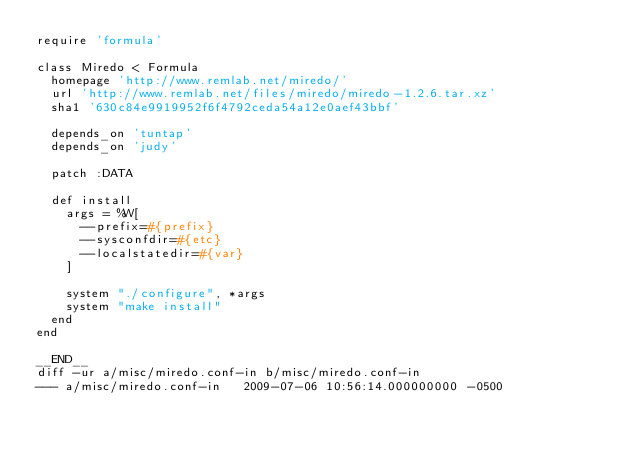Convert code to text. <code><loc_0><loc_0><loc_500><loc_500><_Ruby_>require 'formula'

class Miredo < Formula
  homepage 'http://www.remlab.net/miredo/'
  url 'http://www.remlab.net/files/miredo/miredo-1.2.6.tar.xz'
  sha1 '630c84e9919952f6f4792ceda54a12e0aef43bbf'

  depends_on 'tuntap'
  depends_on 'judy'

  patch :DATA

  def install
    args = %W[
      --prefix=#{prefix}
      --sysconfdir=#{etc}
      --localstatedir=#{var}
    ]

    system "./configure", *args
    system "make install"
  end
end

__END__
diff -ur a/misc/miredo.conf-in b/misc/miredo.conf-in
--- a/misc/miredo.conf-in	2009-07-06 10:56:14.000000000 -0500</code> 